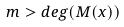<formula> <loc_0><loc_0><loc_500><loc_500>m > d e g ( M ( x ) )</formula> 